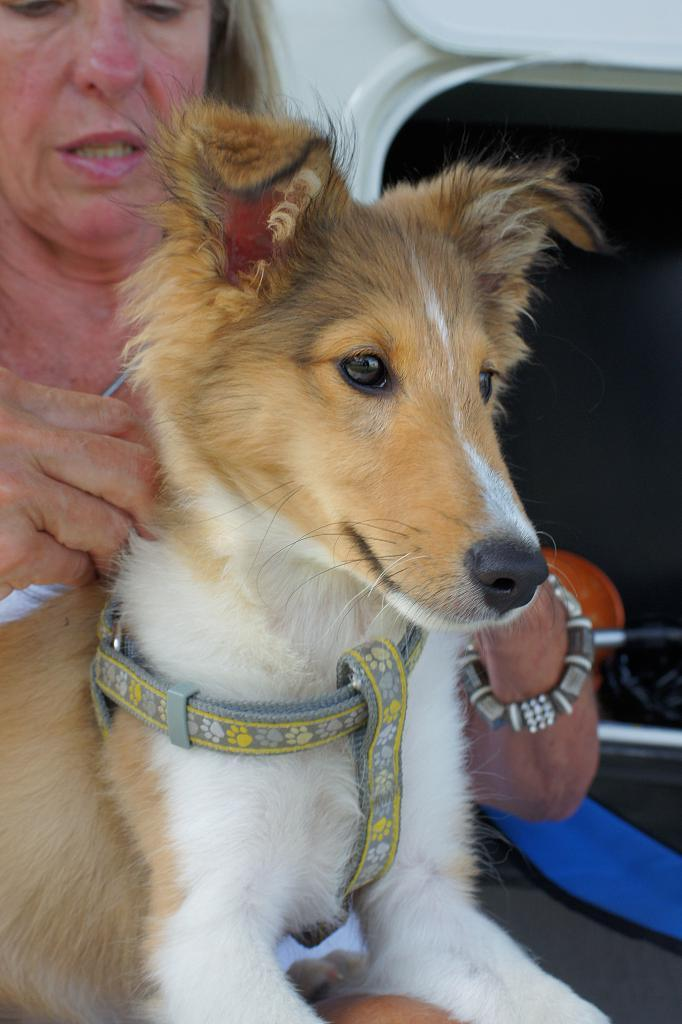What type of animal is in the image? There is a dog in the image. What is the dog wearing? The dog is wearing a dog belt. Who is holding the dog? There is a woman holding the dog. What can be seen in the background of the image? There is a vehicle visible in the background of the image. How many apples can be seen on the dog's back in the image? There are no apples present in the image, and the dog is not carrying any apples on its back. 